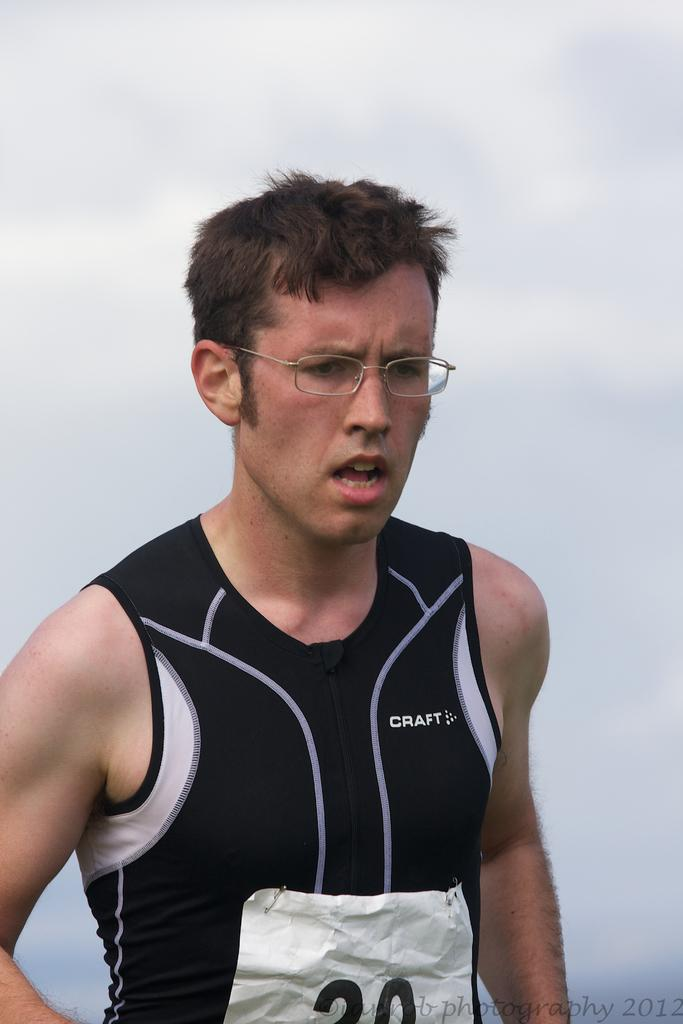<image>
Share a concise interpretation of the image provided. The runner pictured is wearing sports gear made by Craft.. 